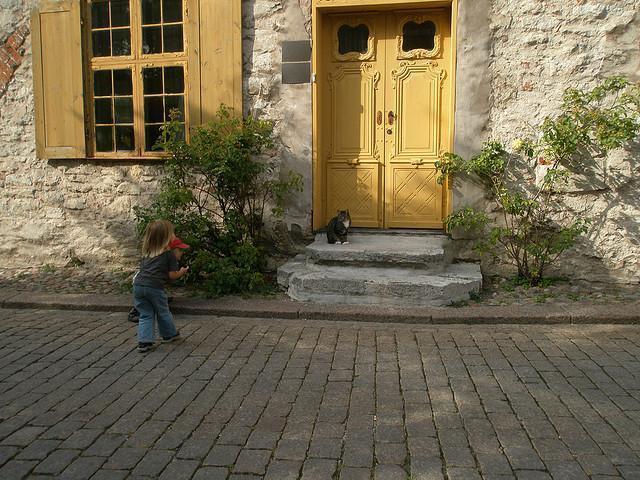How many of the surfboards are yellow?
Give a very brief answer. 0. 